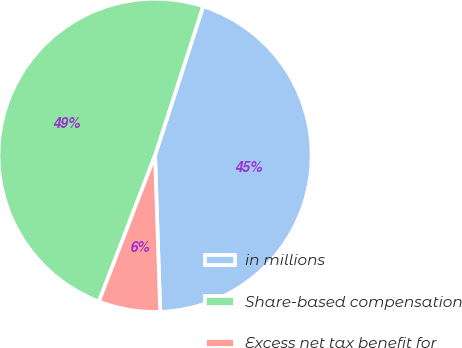Convert chart to OTSL. <chart><loc_0><loc_0><loc_500><loc_500><pie_chart><fcel>in millions<fcel>Share-based compensation<fcel>Excess net tax benefit for<nl><fcel>44.51%<fcel>49.13%<fcel>6.36%<nl></chart> 